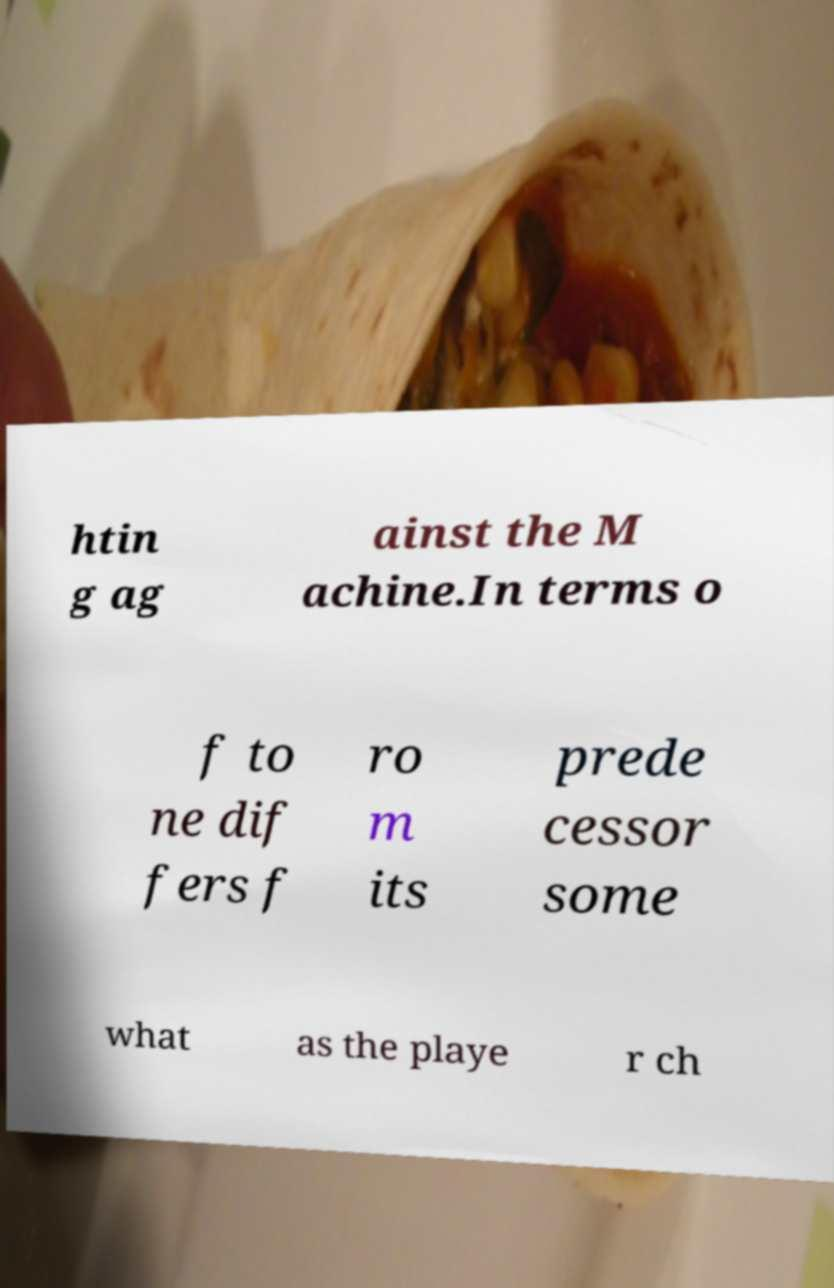Please identify and transcribe the text found in this image. htin g ag ainst the M achine.In terms o f to ne dif fers f ro m its prede cessor some what as the playe r ch 